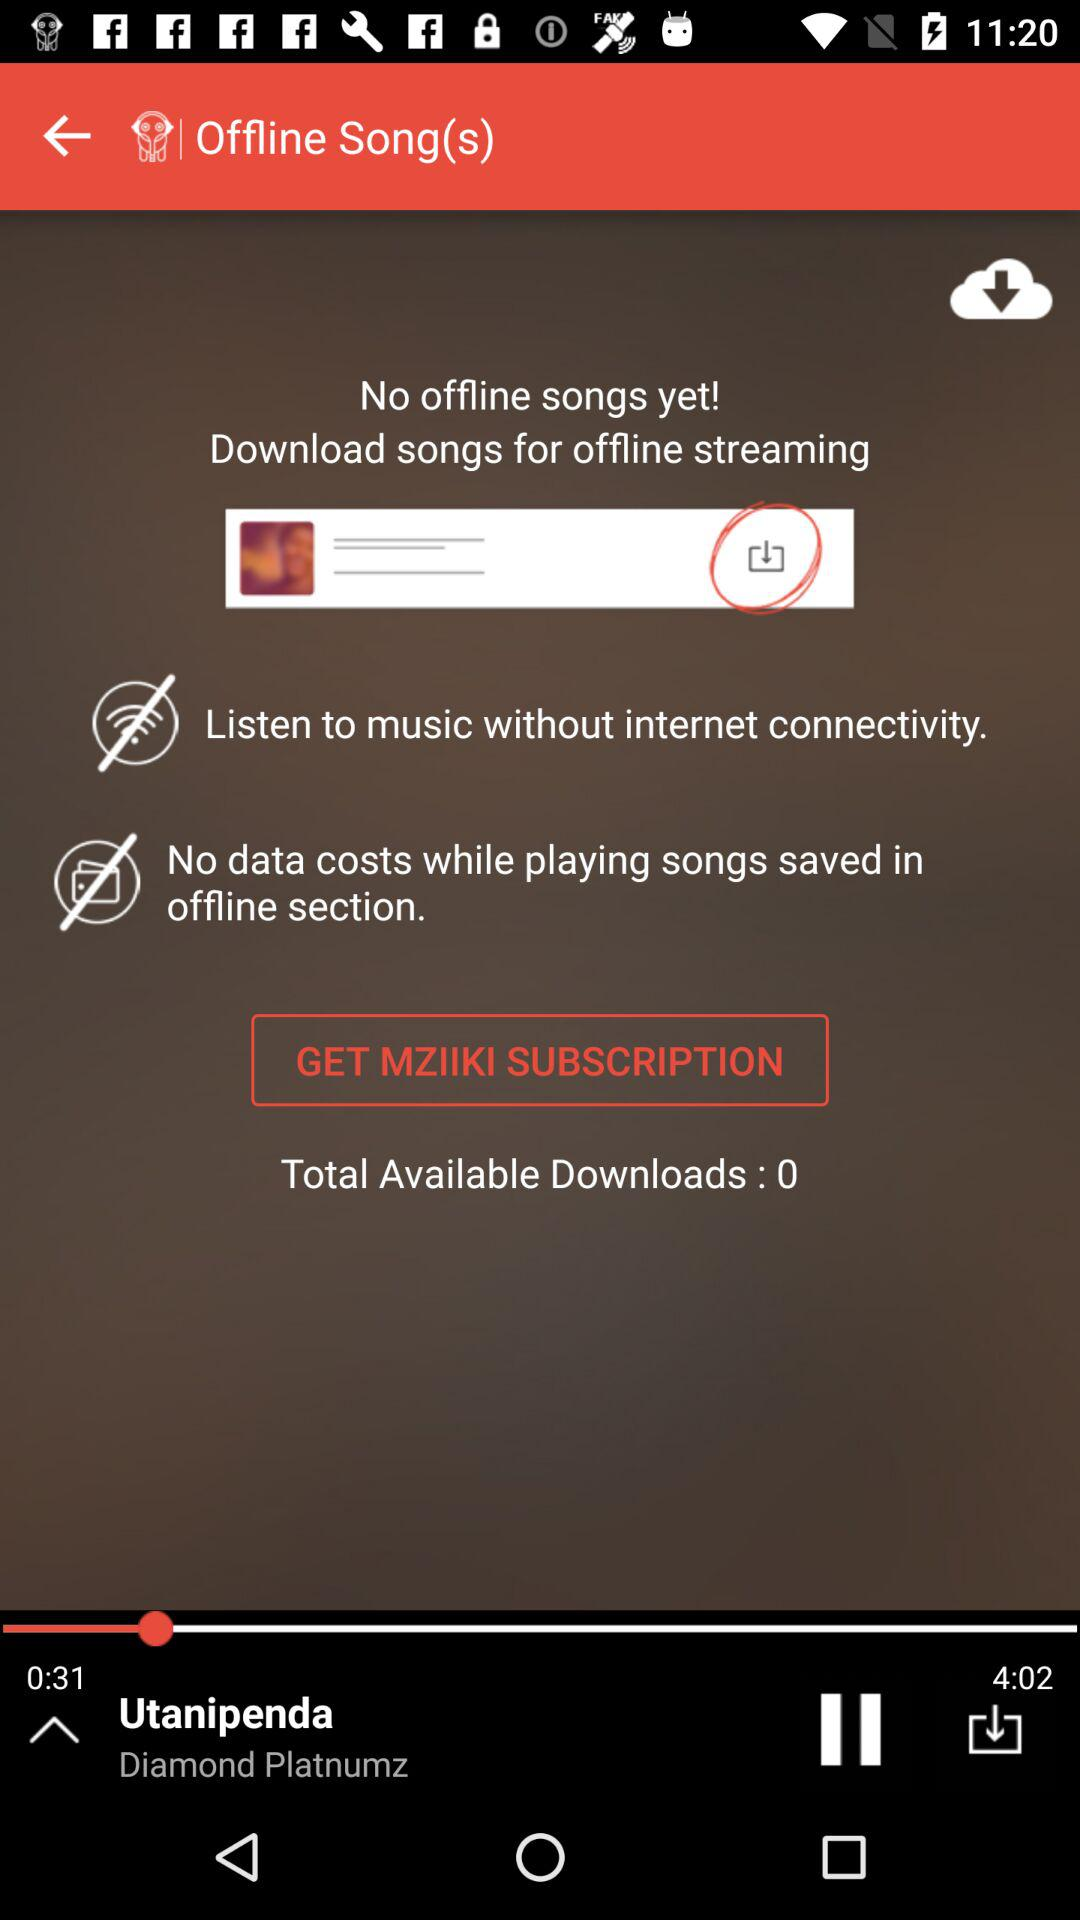What's the "Total Available Downloads"? The "Total Available Downloads" is 0. 